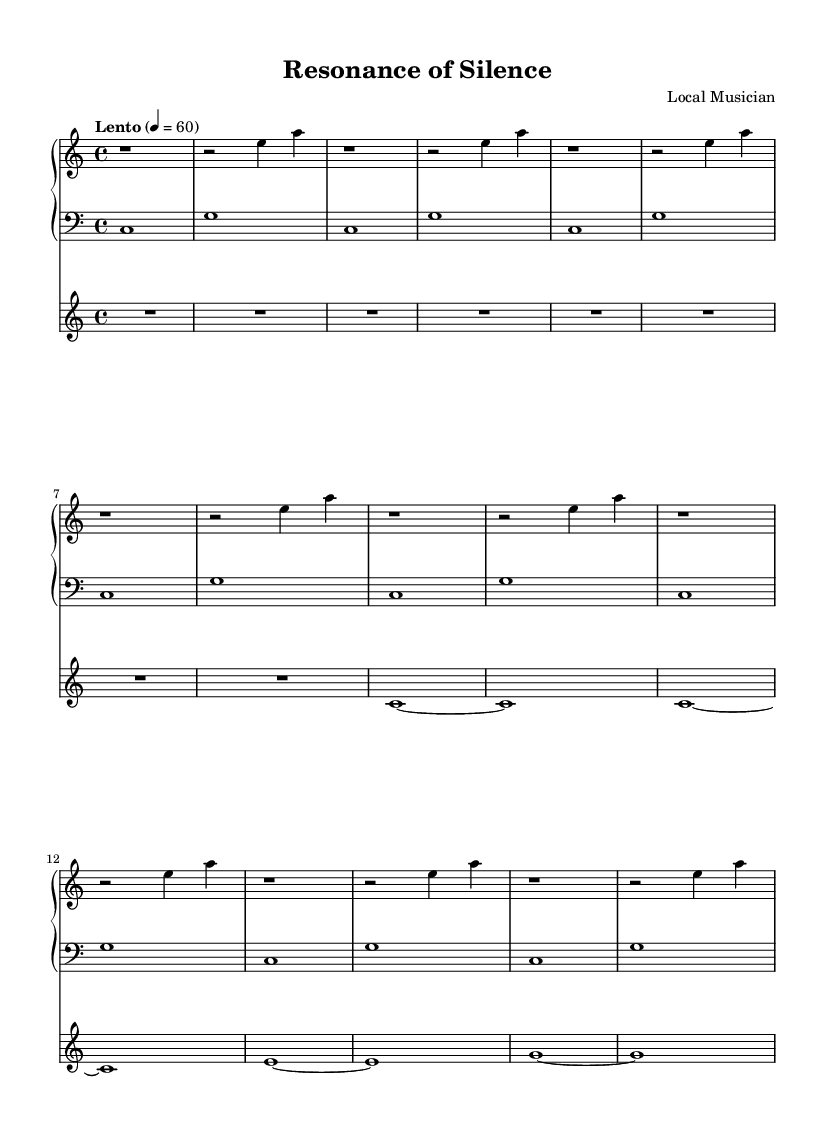What is the key signature of this music? The key signature is C major, which has no sharps or flats.
Answer: C major What is the time signature of this music? The time signature is 4/4, which indicates four beats in each measure.
Answer: 4/4 What is the tempo marking of this piece? The piece has a tempo marking of "Lento" with a metronome mark of 60 beats per minute.
Answer: Lento How many measures are in Section A for the piano? Section A for the piano contains 8 measures, as indicated by the repeated patterns that run across the specified section.
Answer: 8 measures What is the dynamic marking indicated for the violin in the introduction? The violin in the introduction is marked with a silent measure (indicated by R1*8), suggesting a pause before the entry.
Answer: Silence How does the left hand in the piano part primarily move in Section A? The left hand in Section A primarily alternates between two notes, C and G, creating a stable harmonic foundation.
Answer: C and G What is the emotional intention behind the repeated motifs in this minimalist piece? The repeated motifs create a meditative atmosphere, inviting the listener to engage emotionally with the subtle variations and silence.
Answer: Meditative 